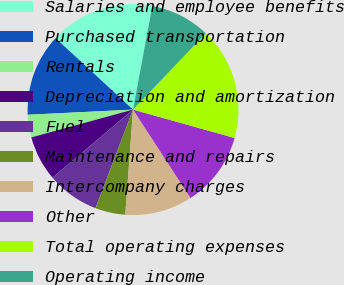Convert chart to OTSL. <chart><loc_0><loc_0><loc_500><loc_500><pie_chart><fcel>Salaries and employee benefits<fcel>Purchased transportation<fcel>Rentals<fcel>Depreciation and amortization<fcel>Fuel<fcel>Maintenance and repairs<fcel>Intercompany charges<fcel>Other<fcel>Total operating expenses<fcel>Operating income<nl><fcel>16.07%<fcel>12.63%<fcel>3.47%<fcel>6.91%<fcel>8.05%<fcel>4.62%<fcel>10.34%<fcel>11.49%<fcel>17.21%<fcel>9.2%<nl></chart> 